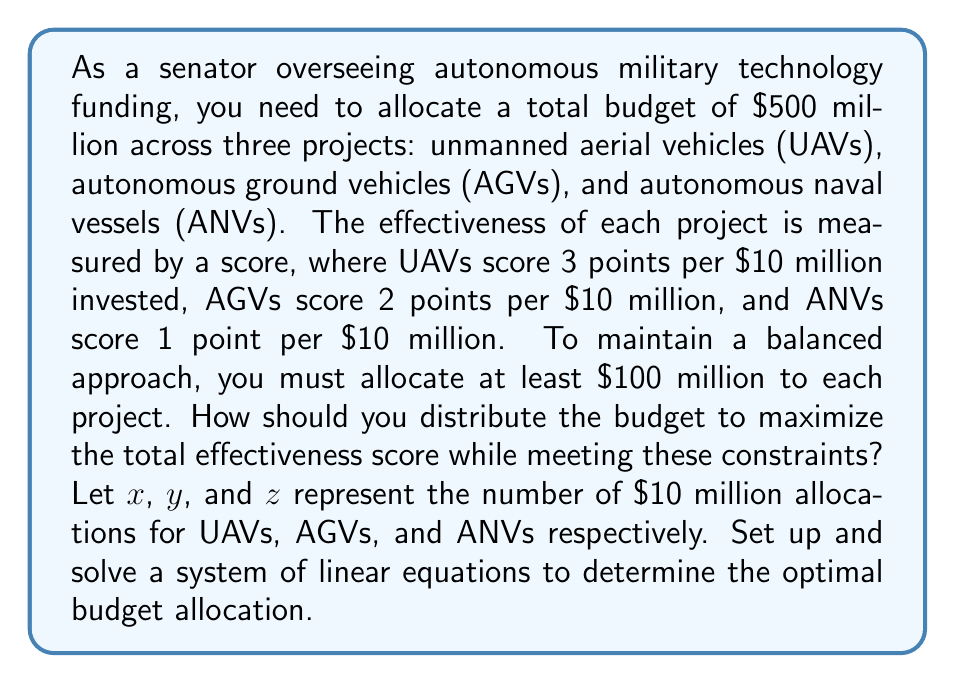Help me with this question. Let's approach this step-by-step:

1) First, let's set up our objective function to maximize:
   Total Score = $3x + 2y + z$

2) Now, let's define our constraints:
   a) Total budget constraint: $10x + 10y + 10z = 500$ (in millions)
   b) Minimum allocation constraints:
      $10x \geq 100$, $10y \geq 100$, $10z \geq 100$

3) Simplifying the constraints:
   a) $x + y + z = 50$
   b) $x \geq 10$, $y \geq 10$, $z \geq 10$

4) To maximize the score, we should allocate as much as possible to the higher-scoring projects while meeting the minimum requirements for all. This means:
   - Allocate the minimum to ANVs: $z = 10$
   - Allocate the minimum to AGVs: $y = 10$
   - Allocate the remainder to UAVs: $x = 50 - y - z = 50 - 10 - 10 = 30$

5) Let's verify that this satisfies all constraints:
   - $x + y + z = 30 + 10 + 10 = 50$ ✓
   - $x \geq 10$, $y \geq 10$, $z \geq 10$ ✓

6) Calculate the total score:
   Total Score = $3(30) + 2(10) + 1(10) = 90 + 20 + 10 = 120$

7) Convert back to actual budget amounts:
   UAVs: $30 * 10 = $300 million
   AGVs: $10 * 10 = $100 million
   ANVs: $10 * 10 = $100 million
Answer: UAVs: $300 million, AGVs: $100 million, ANVs: $100 million 